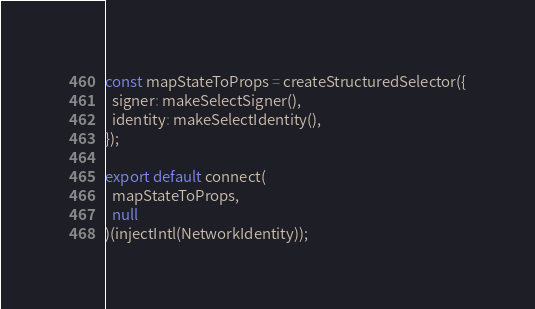<code> <loc_0><loc_0><loc_500><loc_500><_JavaScript_>const mapStateToProps = createStructuredSelector({
  signer: makeSelectSigner(),
  identity: makeSelectIdentity(),
});

export default connect(
  mapStateToProps,
  null
)(injectIntl(NetworkIdentity));
</code> 